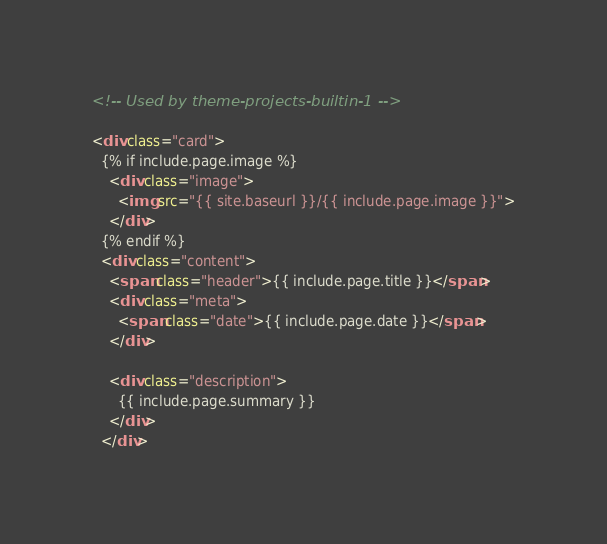Convert code to text. <code><loc_0><loc_0><loc_500><loc_500><_HTML_><!-- Used by theme-projects-builtin-1 -->

<div class="card">
  {% if include.page.image %}
    <div class="image">
      <img src="{{ site.baseurl }}/{{ include.page.image }}">
    </div>
  {% endif %}
  <div class="content">
    <span class="header">{{ include.page.title }}</span>
    <div class="meta">
      <span class="date">{{ include.page.date }}</span>
    </div>

    <div class="description">
      {{ include.page.summary }}
    </div>
  </div>
</code> 